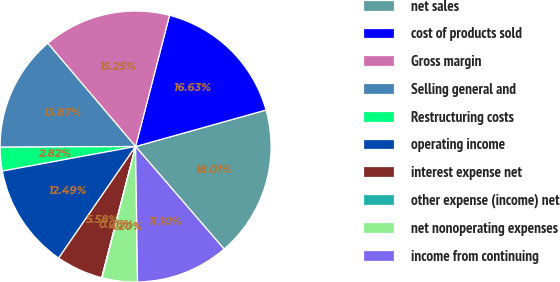Convert chart to OTSL. <chart><loc_0><loc_0><loc_500><loc_500><pie_chart><fcel>net sales<fcel>cost of products sold<fcel>Gross margin<fcel>Selling general and<fcel>Restructuring costs<fcel>operating income<fcel>interest expense net<fcel>other expense (income) net<fcel>net nonoperating expenses<fcel>income from continuing<nl><fcel>18.01%<fcel>16.63%<fcel>15.25%<fcel>13.87%<fcel>2.82%<fcel>12.49%<fcel>5.58%<fcel>0.06%<fcel>4.2%<fcel>11.1%<nl></chart> 